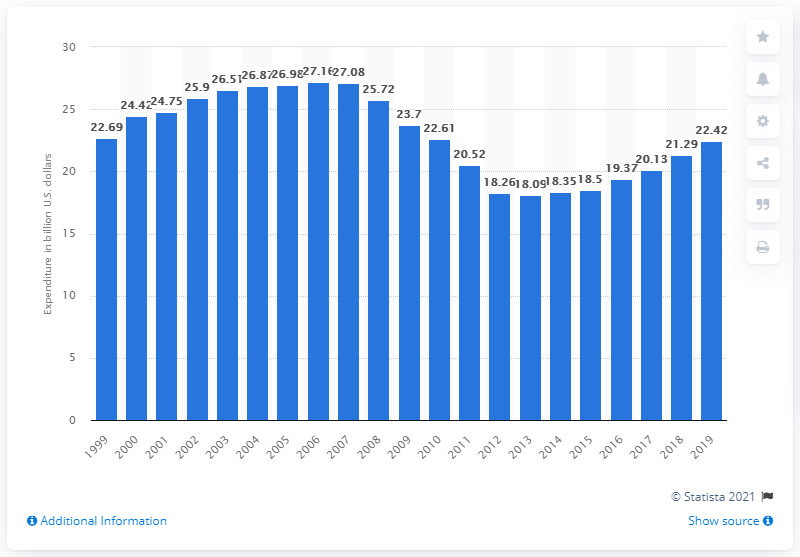What was the consumer expenditure on recreational books in the United States in 2019? In 2019, consumers in the United States spent approximately $22.42 billion on recreational books, reflecting continued engagement with literature and a vibrant publishing industry. 